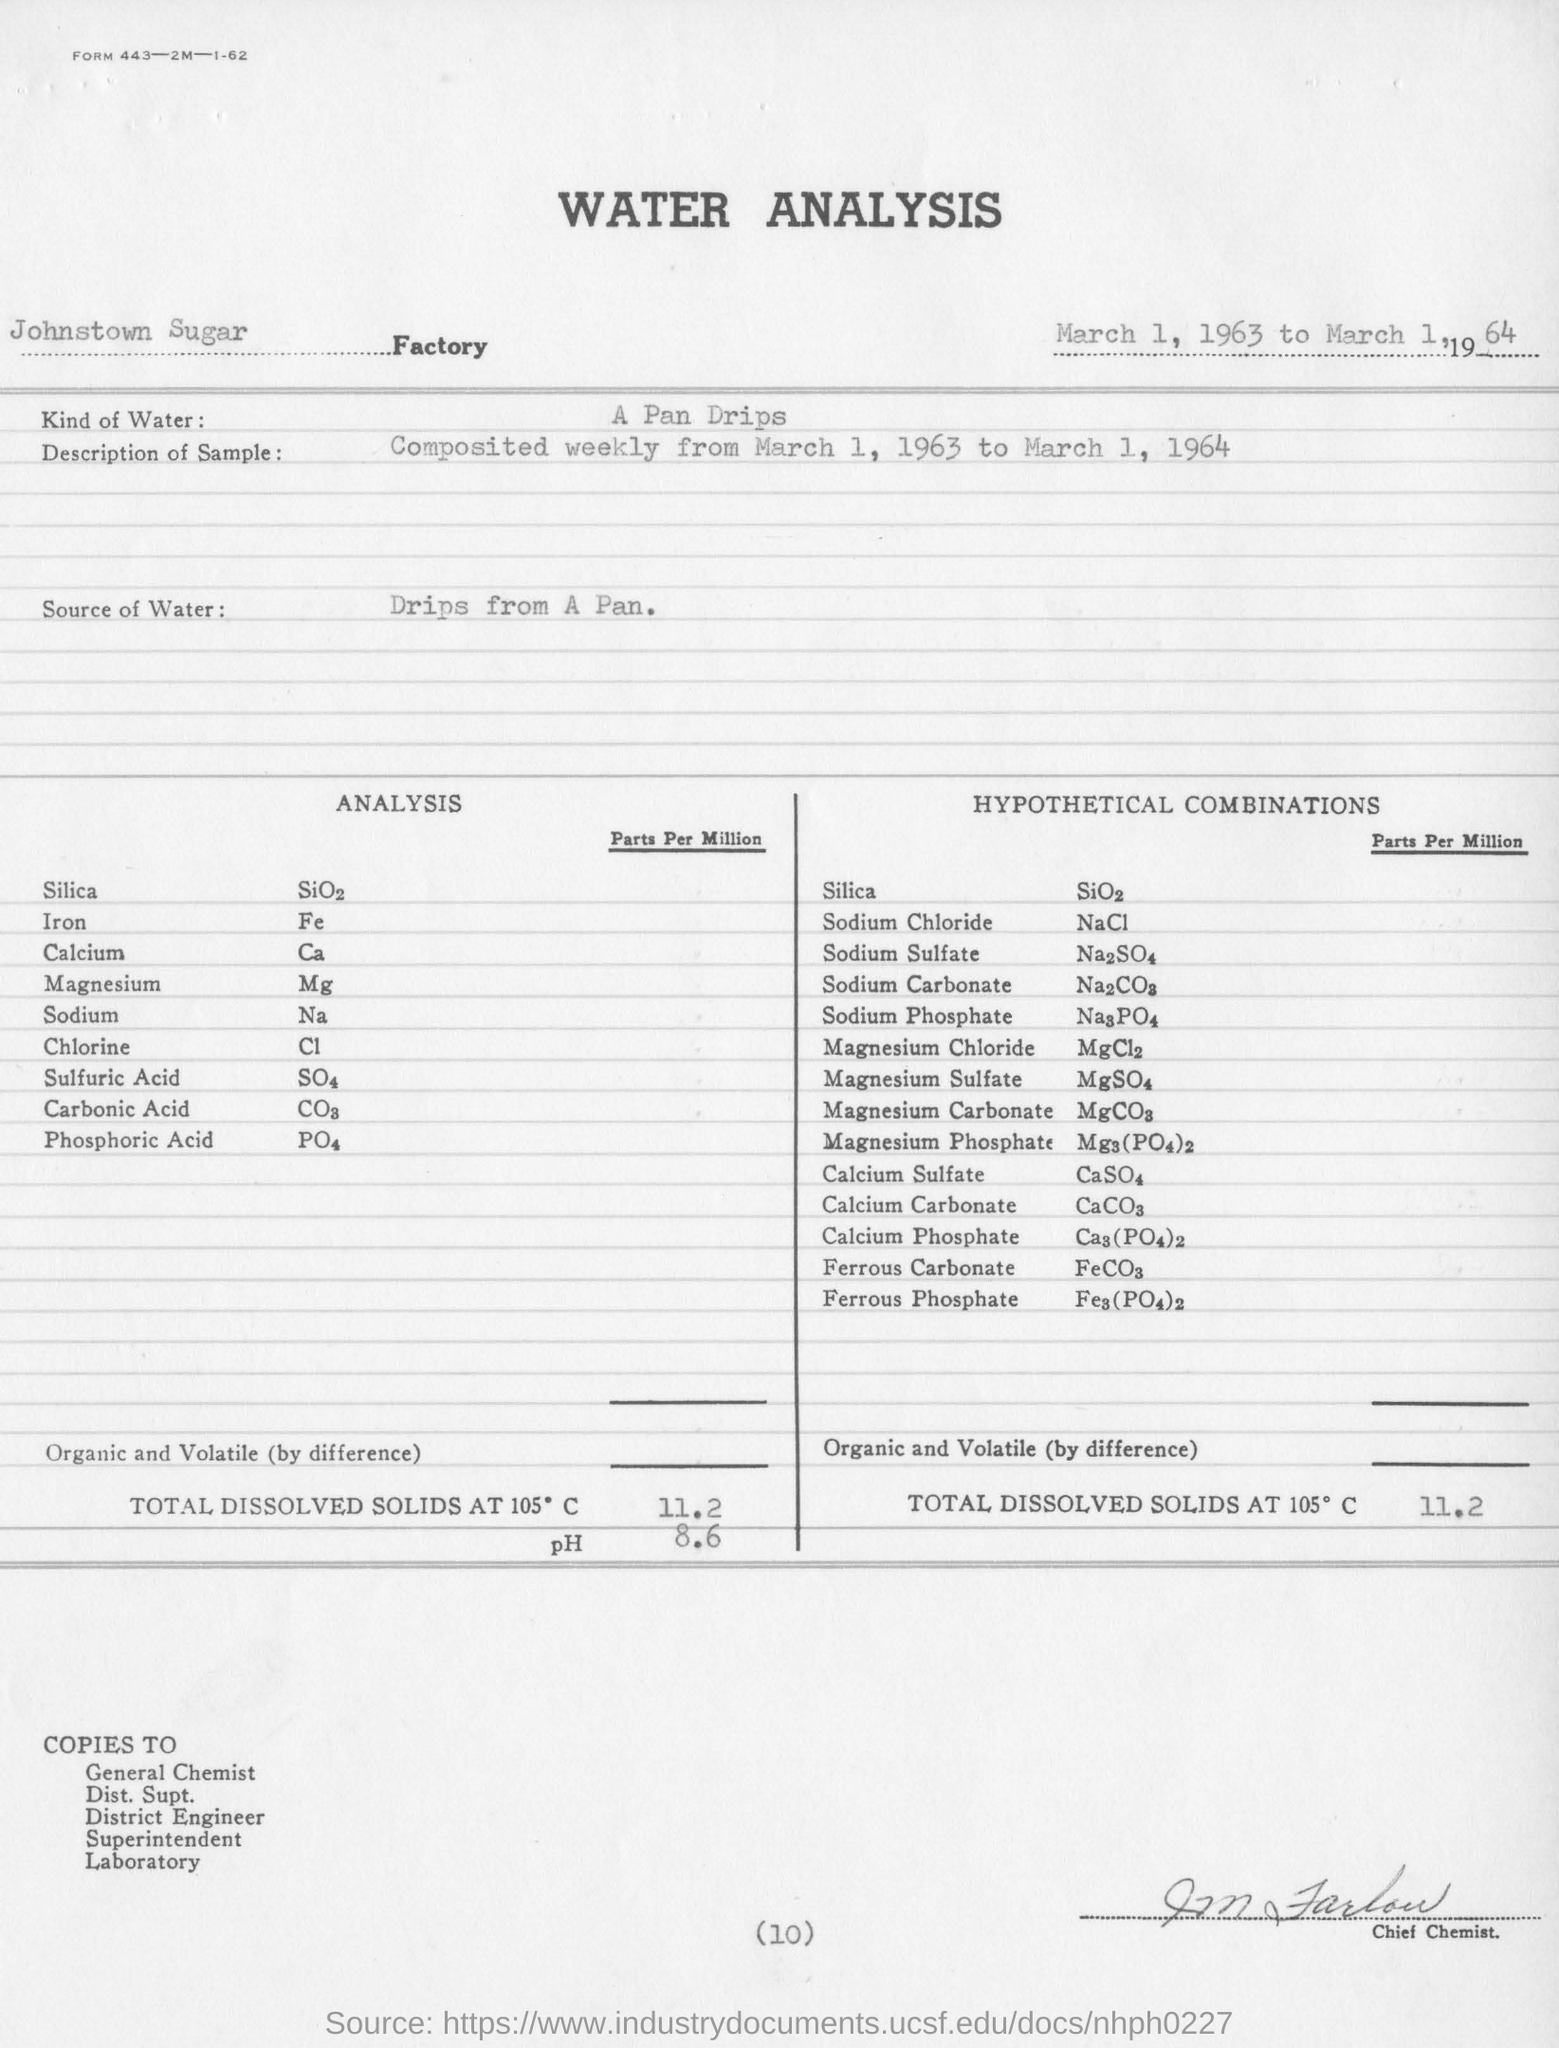Point out several critical features in this image. The chemical formula of sodium chloride is NaCl, which is commonly known as table salt. 